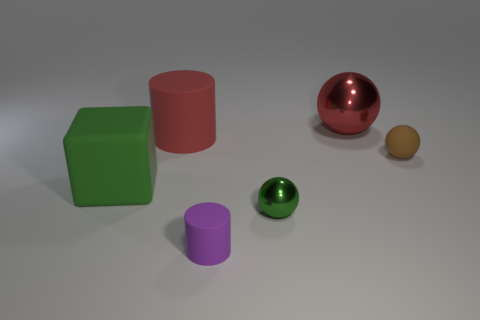Subtract all small brown matte balls. How many balls are left? 2 Add 3 small brown matte balls. How many objects exist? 9 Subtract all red spheres. How many spheres are left? 2 Subtract 2 balls. How many balls are left? 1 Subtract all cylinders. How many objects are left? 4 Subtract all brown balls. Subtract all red cylinders. How many balls are left? 2 Add 1 tiny brown things. How many tiny brown things exist? 2 Subtract 0 blue blocks. How many objects are left? 6 Subtract all brown matte things. Subtract all red cylinders. How many objects are left? 4 Add 2 brown rubber balls. How many brown rubber balls are left? 3 